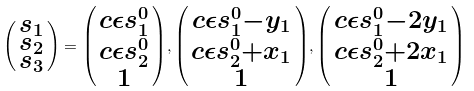Convert formula to latex. <formula><loc_0><loc_0><loc_500><loc_500>\begin{psmallmatrix} s _ { 1 } \\ s _ { 2 } \\ s _ { 3 } \end{psmallmatrix} = \begin{psmallmatrix} c \epsilon s _ { 1 } ^ { 0 } \\ c \epsilon s _ { 2 } ^ { 0 } \\ 1 \end{psmallmatrix} , \begin{psmallmatrix} c \epsilon s _ { 1 } ^ { 0 } - y _ { 1 } \\ c \epsilon s _ { 2 } ^ { 0 } + x _ { 1 } \\ 1 \end{psmallmatrix} , \begin{psmallmatrix} c \epsilon s _ { 1 } ^ { 0 } - 2 y _ { 1 } \\ c \epsilon s _ { 2 } ^ { 0 } + 2 x _ { 1 } \\ 1 \end{psmallmatrix}</formula> 